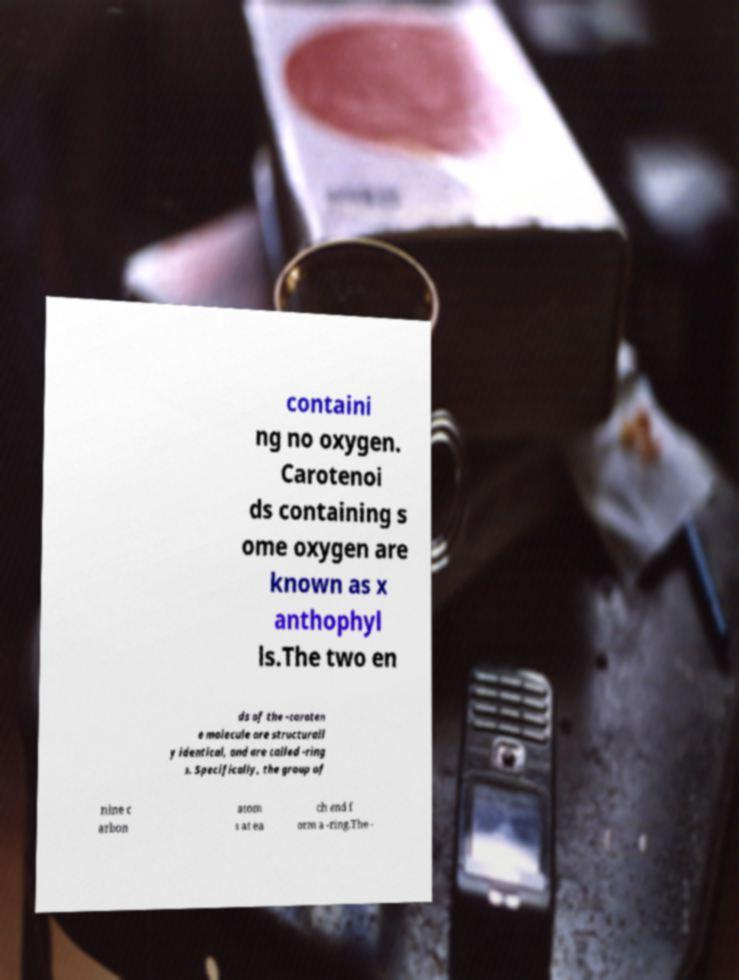Can you accurately transcribe the text from the provided image for me? containi ng no oxygen. Carotenoi ds containing s ome oxygen are known as x anthophyl ls.The two en ds of the -caroten e molecule are structurall y identical, and are called -ring s. Specifically, the group of nine c arbon atom s at ea ch end f orm a -ring.The - 